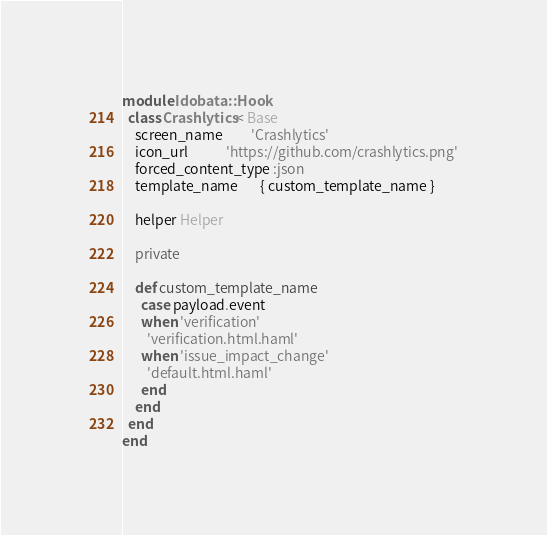<code> <loc_0><loc_0><loc_500><loc_500><_Ruby_>module Idobata::Hook
  class Crashlytics < Base
    screen_name         'Crashlytics'
    icon_url            'https://github.com/crashlytics.png'
    forced_content_type :json
    template_name       { custom_template_name }

    helper Helper

    private

    def custom_template_name
      case payload.event
      when 'verification'
        'verification.html.haml'
      when 'issue_impact_change'
        'default.html.haml'
      end
    end
  end
end
</code> 